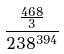<formula> <loc_0><loc_0><loc_500><loc_500>\frac { \frac { 4 6 8 } { 3 } } { 2 3 8 ^ { 3 9 4 } }</formula> 